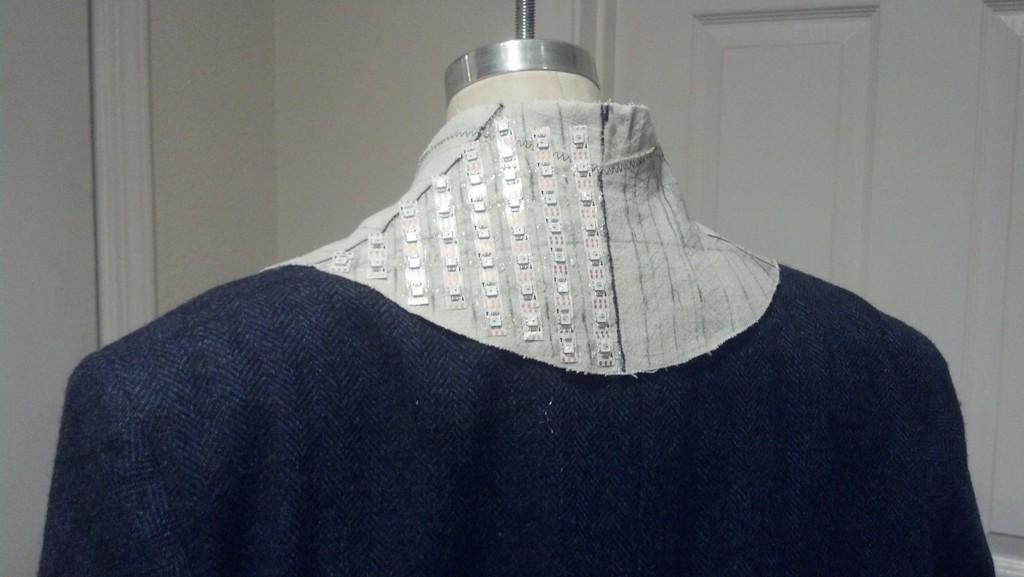Could you give a brief overview of what you see in this image? In this image there is a dress to a mannequin, there is a door and the wall. 